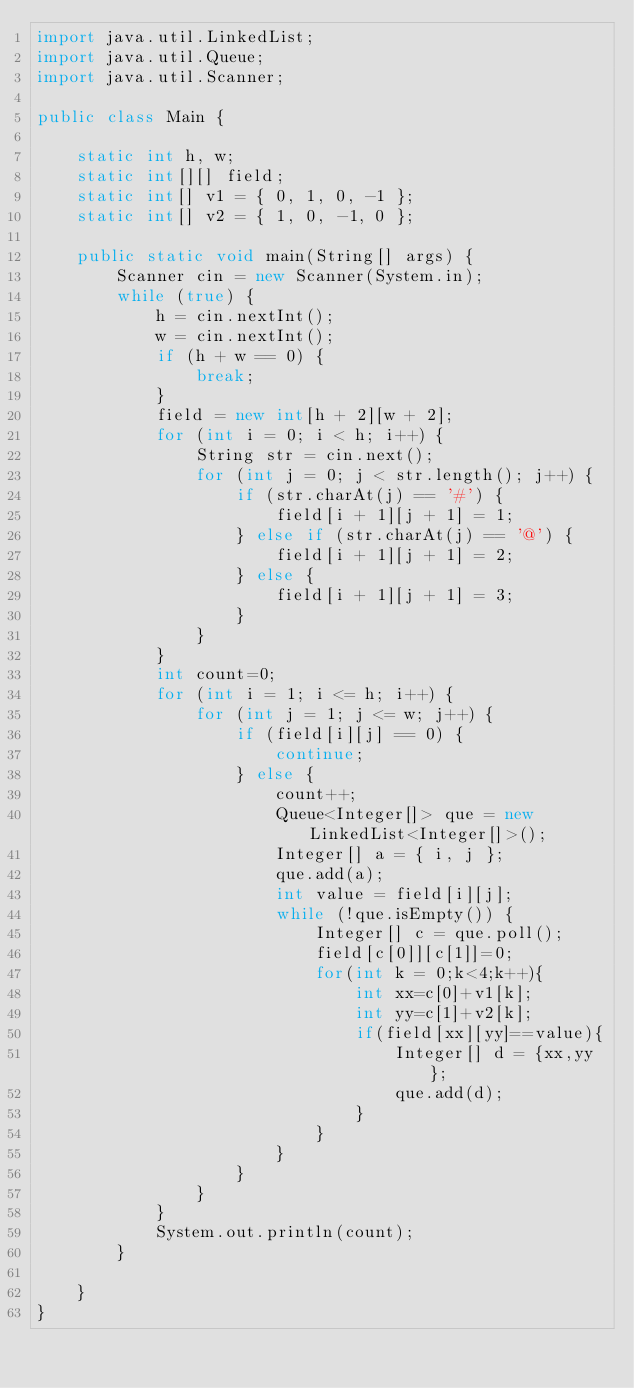<code> <loc_0><loc_0><loc_500><loc_500><_Java_>import java.util.LinkedList;
import java.util.Queue;
import java.util.Scanner;

public class Main {

	static int h, w;
	static int[][] field;
	static int[] v1 = { 0, 1, 0, -1 };
	static int[] v2 = { 1, 0, -1, 0 };

	public static void main(String[] args) {
		Scanner cin = new Scanner(System.in);
		while (true) {
			h = cin.nextInt();
			w = cin.nextInt();
			if (h + w == 0) {
				break;
			}
			field = new int[h + 2][w + 2];
			for (int i = 0; i < h; i++) {
				String str = cin.next();
				for (int j = 0; j < str.length(); j++) {
					if (str.charAt(j) == '#') {
						field[i + 1][j + 1] = 1;
					} else if (str.charAt(j) == '@') {
						field[i + 1][j + 1] = 2;
					} else {
						field[i + 1][j + 1] = 3;
					}
				}
			}
			int count=0;
			for (int i = 1; i <= h; i++) {
				for (int j = 1; j <= w; j++) {
					if (field[i][j] == 0) {
						continue;
					} else {
						count++;
						Queue<Integer[]> que = new LinkedList<Integer[]>();
						Integer[] a = { i, j };
						que.add(a);
						int value = field[i][j];
						while (!que.isEmpty()) {
							Integer[] c = que.poll();
							field[c[0]][c[1]]=0;
							for(int k = 0;k<4;k++){
								int xx=c[0]+v1[k];
								int yy=c[1]+v2[k];
								if(field[xx][yy]==value){
									Integer[] d = {xx,yy};
									que.add(d);
								}
							}
						}
					}
				}
			}
			System.out.println(count);
		}

	}
}</code> 